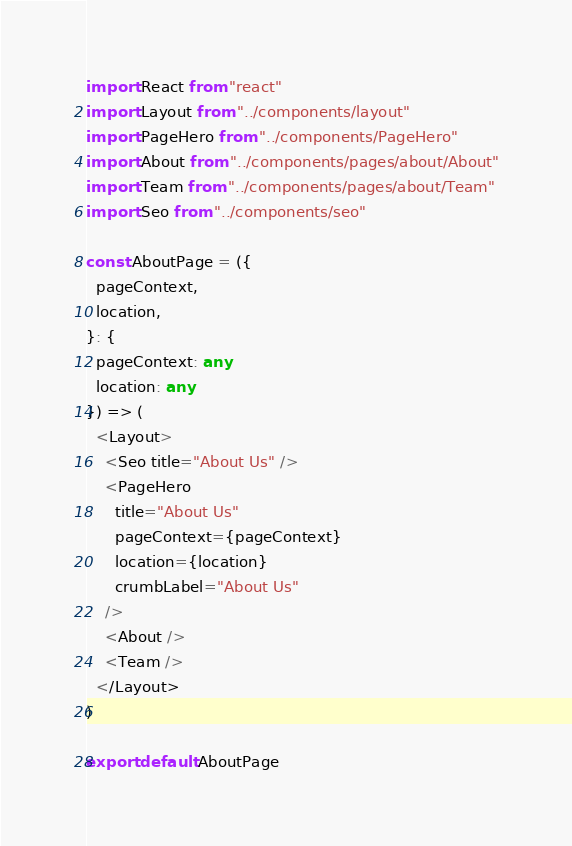Convert code to text. <code><loc_0><loc_0><loc_500><loc_500><_TypeScript_>import React from "react"
import Layout from "../components/layout"
import PageHero from "../components/PageHero"
import About from "../components/pages/about/About"
import Team from "../components/pages/about/Team"
import Seo from "../components/seo"

const AboutPage = ({
  pageContext,
  location,
}: {
  pageContext: any
  location: any
}) => (
  <Layout>
    <Seo title="About Us" />
    <PageHero
      title="About Us"
      pageContext={pageContext}
      location={location}
      crumbLabel="About Us"
    />
    <About />
    <Team />
  </Layout>
)

export default AboutPage
</code> 